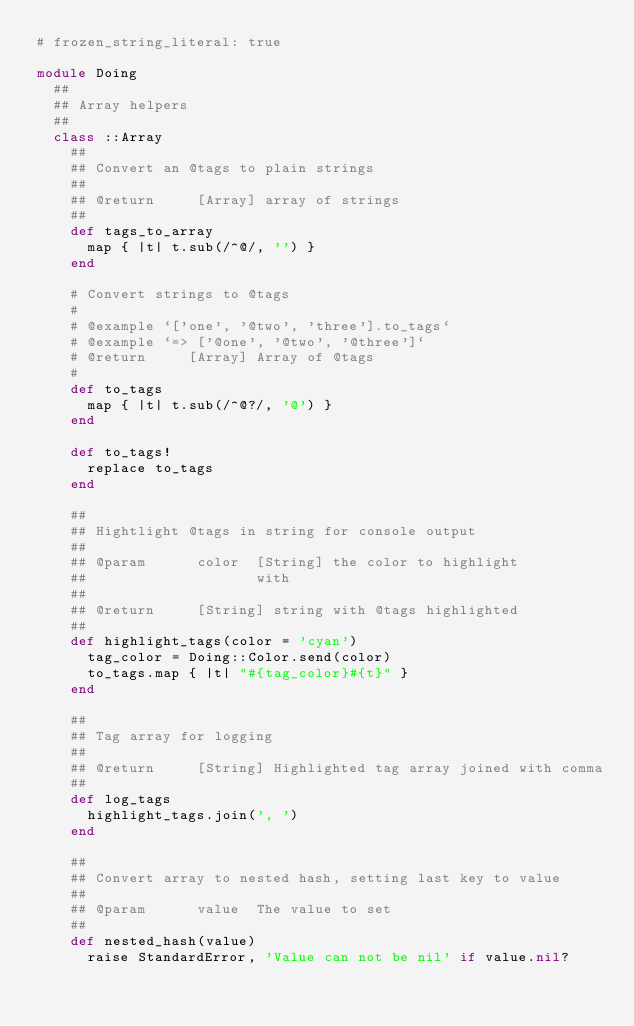<code> <loc_0><loc_0><loc_500><loc_500><_Ruby_># frozen_string_literal: true

module Doing
  ##
  ## Array helpers
  ##
  class ::Array
    ##
    ## Convert an @tags to plain strings
    ##
    ## @return     [Array] array of strings
    ##
    def tags_to_array
      map { |t| t.sub(/^@/, '') }
    end

    # Convert strings to @tags
    #
    # @example `['one', '@two', 'three'].to_tags`
    # @example `=> ['@one', '@two', '@three']`
    # @return     [Array] Array of @tags
    #
    def to_tags
      map { |t| t.sub(/^@?/, '@') }
    end

    def to_tags!
      replace to_tags
    end

    ##
    ## Hightlight @tags in string for console output
    ##
    ## @param      color  [String] the color to highlight
    ##                    with
    ##
    ## @return     [String] string with @tags highlighted
    ##
    def highlight_tags(color = 'cyan')
      tag_color = Doing::Color.send(color)
      to_tags.map { |t| "#{tag_color}#{t}" }
    end

    ##
    ## Tag array for logging
    ##
    ## @return     [String] Highlighted tag array joined with comma
    ##
    def log_tags
      highlight_tags.join(', ')
    end

    ##
    ## Convert array to nested hash, setting last key to value
    ##
    ## @param      value  The value to set
    ##
    def nested_hash(value)
      raise StandardError, 'Value can not be nil' if value.nil?
</code> 